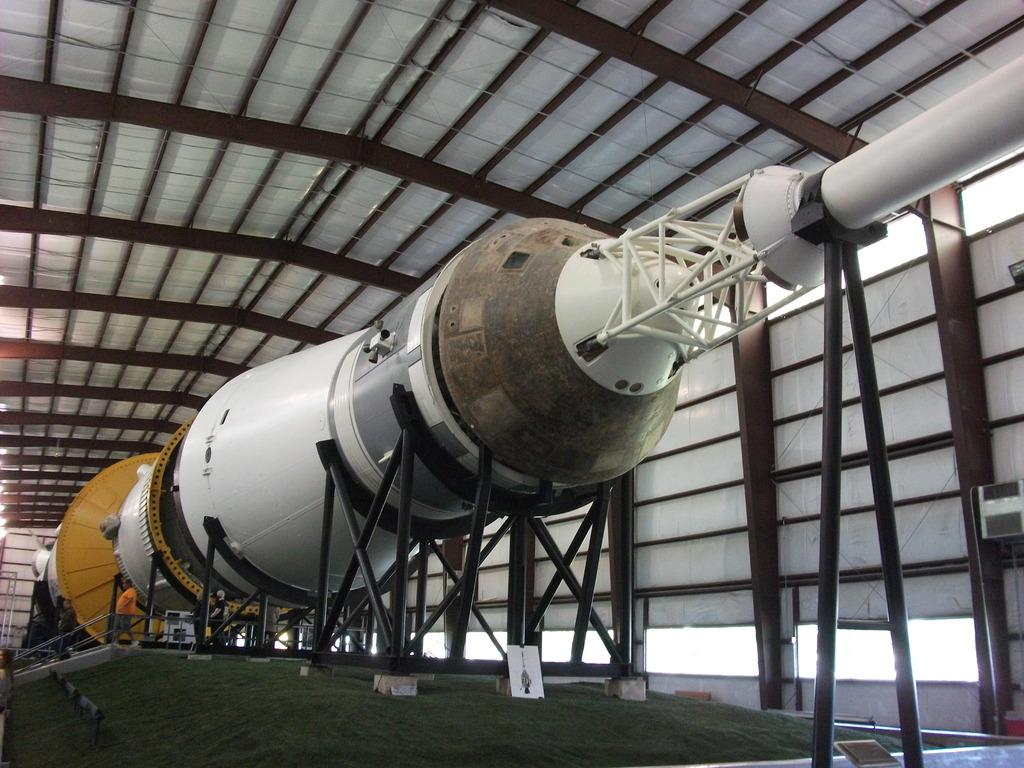What is the main subject of the image? The main subject of the image is a rocket. How is the rocket positioned in the image? The rocket is placed on stands. Can you describe the person in the image? There is a person standing on the left side of the image. What can be seen in the background of the image? There is a shed and a group of poles in the background of the image. What type of soup is being served in the rocket in the image? There is no soup present in the image; it features a rocket on stands with a person nearby and a shed and group of poles in the background. 